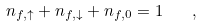<formula> <loc_0><loc_0><loc_500><loc_500>n _ { f , \uparrow } + n _ { f , \downarrow } + n _ { f , 0 } = 1 \quad ,</formula> 